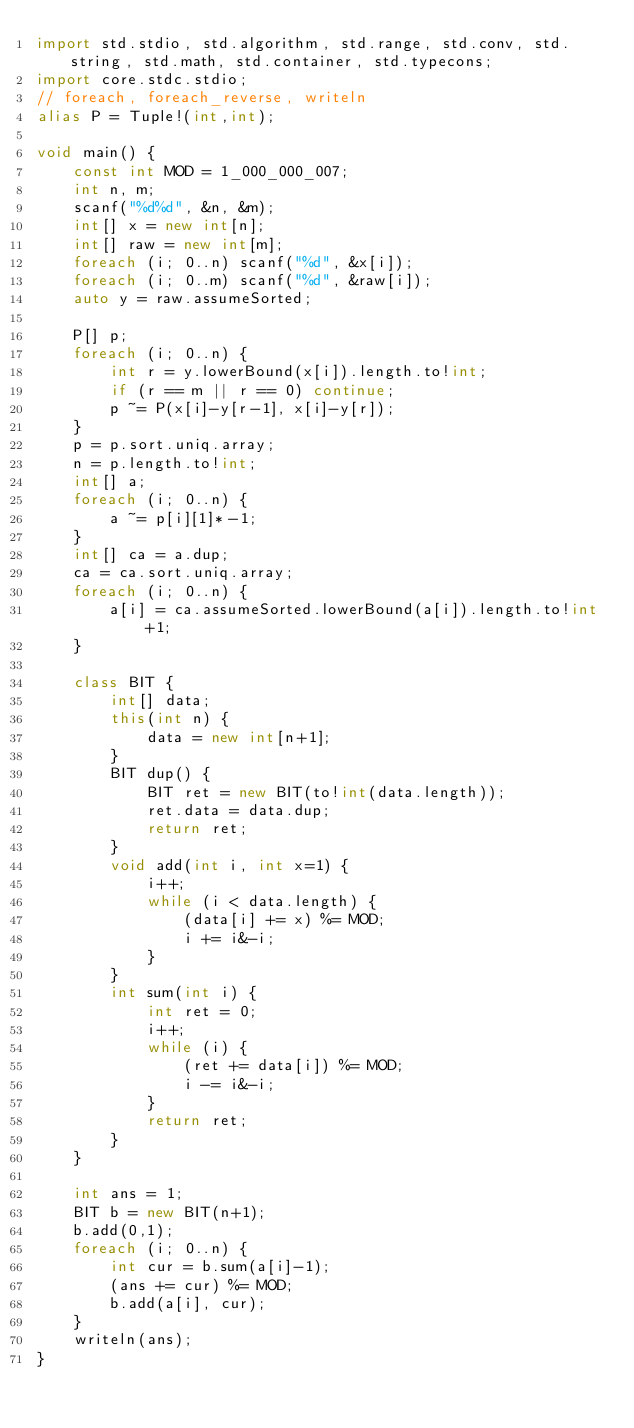Convert code to text. <code><loc_0><loc_0><loc_500><loc_500><_D_>import std.stdio, std.algorithm, std.range, std.conv, std.string, std.math, std.container, std.typecons;
import core.stdc.stdio;
// foreach, foreach_reverse, writeln
alias P = Tuple!(int,int);

void main() {
	const int MOD = 1_000_000_007;
	int n, m;
	scanf("%d%d", &n, &m);
	int[] x = new int[n];
	int[] raw = new int[m];
	foreach (i; 0..n) scanf("%d", &x[i]);
	foreach (i; 0..m) scanf("%d", &raw[i]);
	auto y = raw.assumeSorted;

	P[] p;
	foreach (i; 0..n) {
		int r = y.lowerBound(x[i]).length.to!int;
		if (r == m || r == 0) continue;
		p ~= P(x[i]-y[r-1], x[i]-y[r]);
	}
	p = p.sort.uniq.array;
	n = p.length.to!int;
	int[] a;
	foreach (i; 0..n) {
		a ~= p[i][1]*-1;
	}
	int[] ca = a.dup;
	ca = ca.sort.uniq.array;
	foreach (i; 0..n) {
		a[i] = ca.assumeSorted.lowerBound(a[i]).length.to!int+1;
	}

	class BIT {
		int[] data;
		this(int n) {
			data = new int[n+1];
		}
		BIT dup() {
			BIT ret = new BIT(to!int(data.length));
			ret.data = data.dup;
			return ret;
		}
		void add(int i, int x=1) {
			i++;
			while (i < data.length) {
				(data[i] += x) %= MOD;
				i += i&-i;
			}
		}
		int sum(int i) {
			int ret = 0;
			i++;
			while (i) {
				(ret += data[i]) %= MOD;
				i -= i&-i;
			}
			return ret;
		}
	}

	int ans = 1;
	BIT b = new BIT(n+1);
	b.add(0,1);
	foreach (i; 0..n) {
		int cur = b.sum(a[i]-1);
		(ans += cur) %= MOD;
		b.add(a[i], cur);
	}
	writeln(ans);
}</code> 